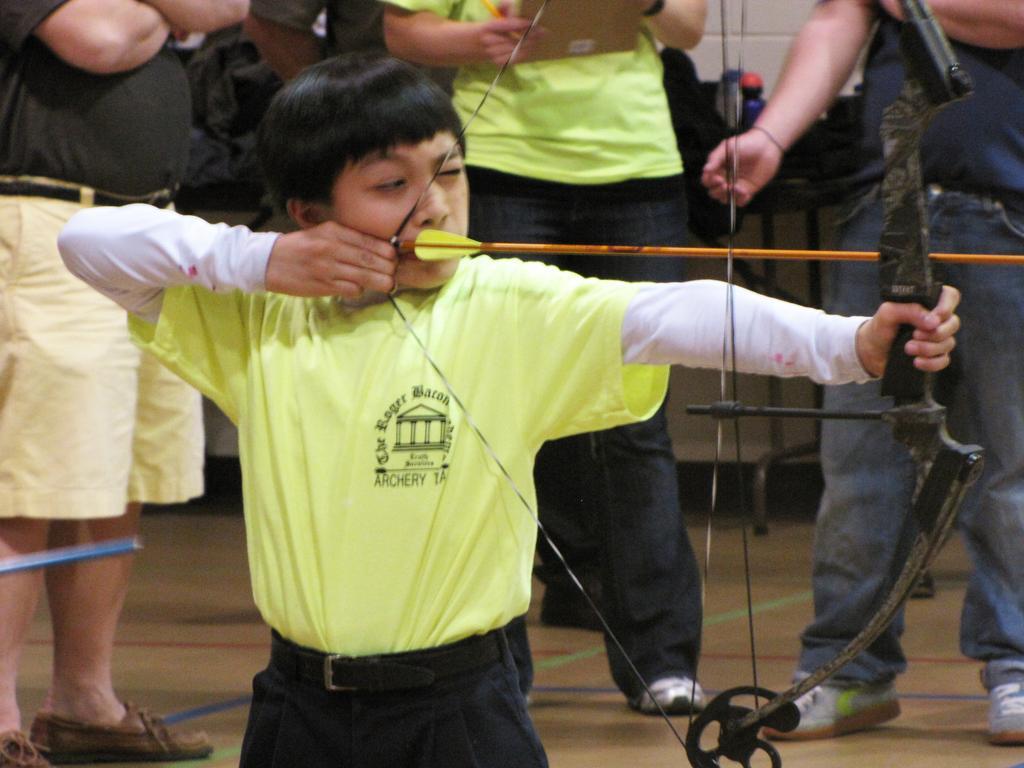Can you describe this image briefly? This image is taken indoors. At the bottom of the image there is a floor. In the background there is a wall and three people are standing on the floor. A man is holding a book in his hands. In the middle of the image a kid is standing on the floor and he is holding an arrow and a bow in his hands. 